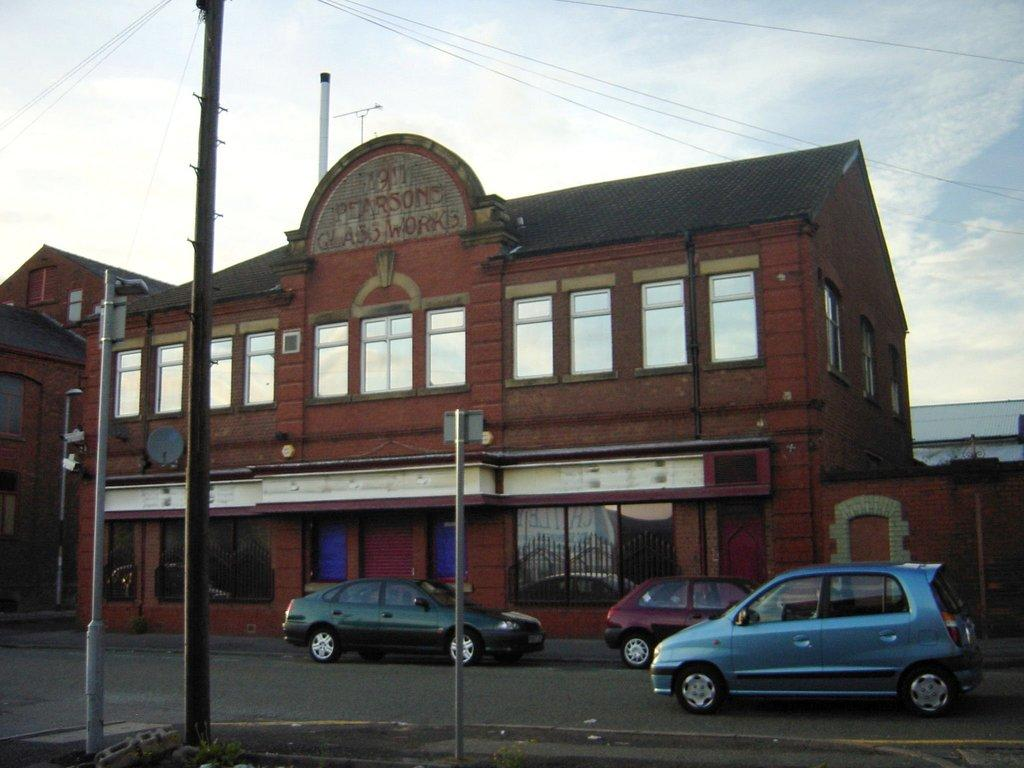What type of vehicles can be seen on the road in the image? There are cars on the road in the image. What kind of structure is visible in the image? There is a building with many windows in the image. What part of the natural environment is visible in the image? The sky is visible in the image. What can be observed in the sky? Clouds are present in the sky. How many bears are sitting on the roof of the building in the image? There are no bears present in the image; it features cars on the road and a building with many windows. What type of bean is being used to decorate the cars in the image? There are no beans present in the image; it features cars on the road and a building with many windows. 